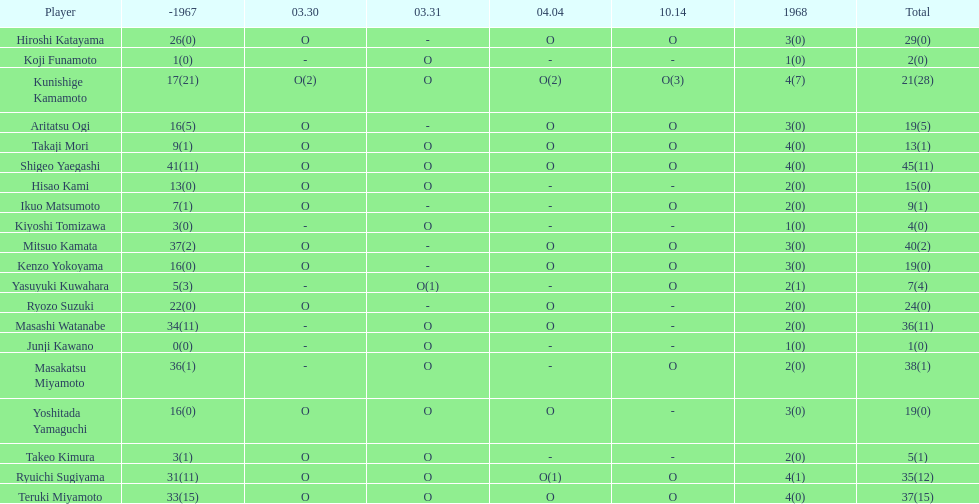How many total did mitsuo kamata have? 40(2). 